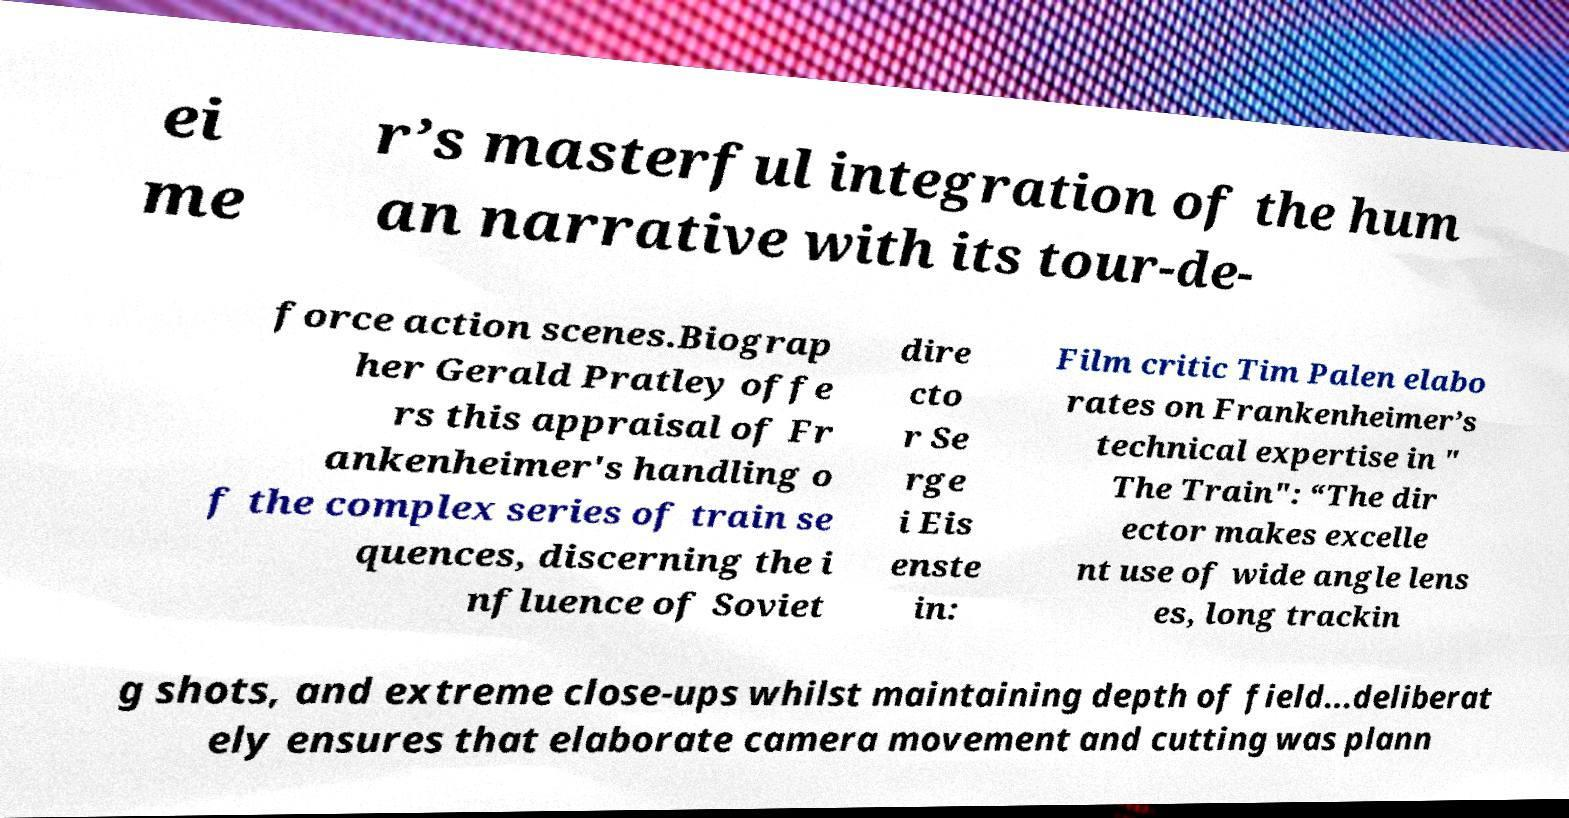Can you read and provide the text displayed in the image?This photo seems to have some interesting text. Can you extract and type it out for me? ei me r’s masterful integration of the hum an narrative with its tour-de- force action scenes.Biograp her Gerald Pratley offe rs this appraisal of Fr ankenheimer's handling o f the complex series of train se quences, discerning the i nfluence of Soviet dire cto r Se rge i Eis enste in: Film critic Tim Palen elabo rates on Frankenheimer’s technical expertise in " The Train": “The dir ector makes excelle nt use of wide angle lens es, long trackin g shots, and extreme close-ups whilst maintaining depth of field...deliberat ely ensures that elaborate camera movement and cutting was plann 